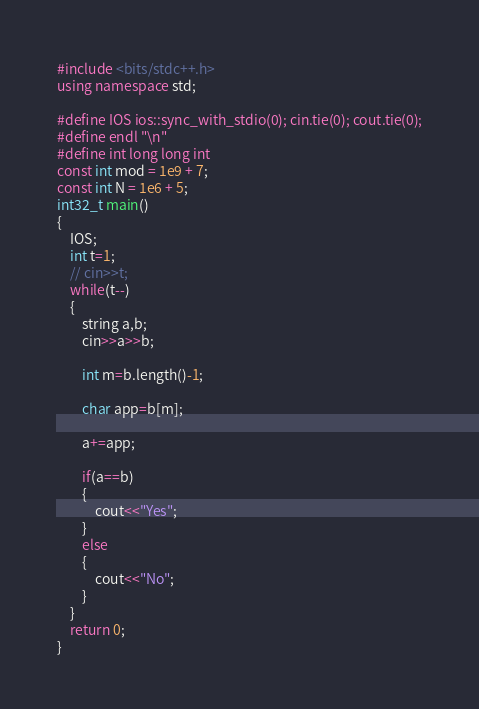<code> <loc_0><loc_0><loc_500><loc_500><_C++_>#include <bits/stdc++.h>
using namespace std;
 
#define IOS ios::sync_with_stdio(0); cin.tie(0); cout.tie(0);
#define endl "\n"
#define int long long int
const int mod = 1e9 + 7;
const int N = 1e6 + 5;
int32_t main()
{
	IOS;
	int t=1;
	// cin>>t;
	while(t--)
	{
		string a,b;
		cin>>a>>b;

		int m=b.length()-1;

		char app=b[m];

		a+=app;

		if(a==b)
		{
			cout<<"Yes";
		}
		else
		{
			cout<<"No";
		}
	}
	return 0;
}</code> 